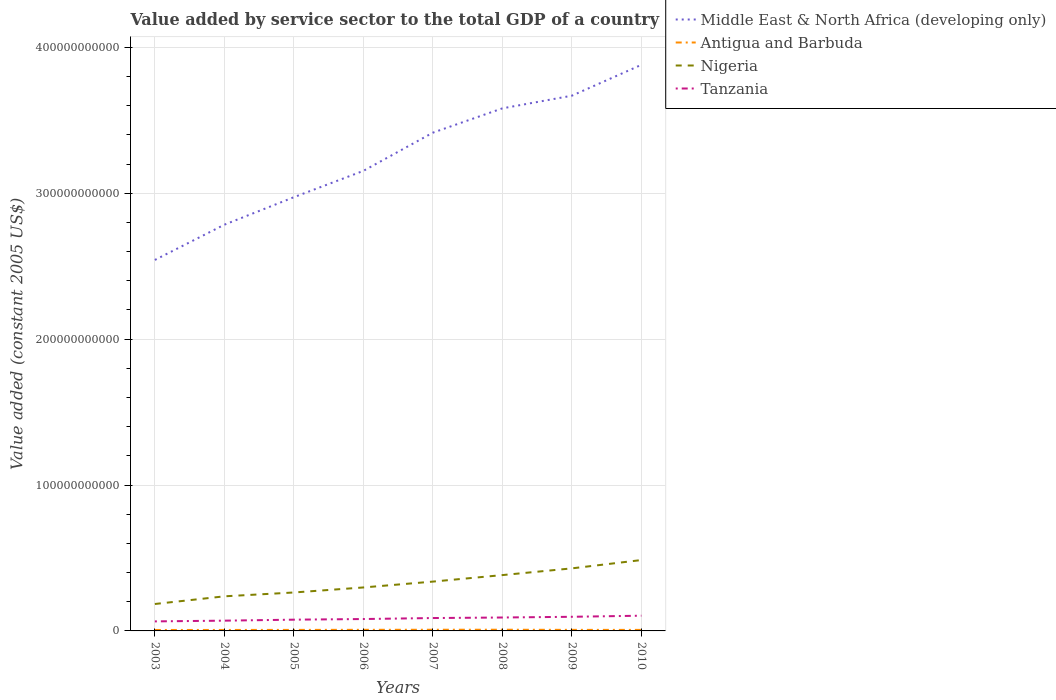How many different coloured lines are there?
Provide a short and direct response. 4. Does the line corresponding to Antigua and Barbuda intersect with the line corresponding to Tanzania?
Provide a succinct answer. No. Across all years, what is the maximum value added by service sector in Middle East & North Africa (developing only)?
Your answer should be very brief. 2.54e+11. What is the total value added by service sector in Nigeria in the graph?
Provide a short and direct response. -4.61e+09. What is the difference between the highest and the second highest value added by service sector in Tanzania?
Provide a succinct answer. 3.91e+09. What is the difference between the highest and the lowest value added by service sector in Antigua and Barbuda?
Keep it short and to the point. 3. How many years are there in the graph?
Your answer should be very brief. 8. What is the difference between two consecutive major ticks on the Y-axis?
Provide a short and direct response. 1.00e+11. How many legend labels are there?
Your response must be concise. 4. What is the title of the graph?
Provide a succinct answer. Value added by service sector to the total GDP of a country. Does "Paraguay" appear as one of the legend labels in the graph?
Your answer should be compact. No. What is the label or title of the X-axis?
Ensure brevity in your answer.  Years. What is the label or title of the Y-axis?
Provide a short and direct response. Value added (constant 2005 US$). What is the Value added (constant 2005 US$) of Middle East & North Africa (developing only) in 2003?
Your answer should be very brief. 2.54e+11. What is the Value added (constant 2005 US$) of Antigua and Barbuda in 2003?
Give a very brief answer. 6.45e+08. What is the Value added (constant 2005 US$) in Nigeria in 2003?
Provide a succinct answer. 1.85e+1. What is the Value added (constant 2005 US$) in Tanzania in 2003?
Your answer should be compact. 6.53e+09. What is the Value added (constant 2005 US$) in Middle East & North Africa (developing only) in 2004?
Your answer should be very brief. 2.78e+11. What is the Value added (constant 2005 US$) in Antigua and Barbuda in 2004?
Provide a succinct answer. 6.69e+08. What is the Value added (constant 2005 US$) of Nigeria in 2004?
Offer a terse response. 2.37e+1. What is the Value added (constant 2005 US$) in Tanzania in 2004?
Provide a short and direct response. 7.04e+09. What is the Value added (constant 2005 US$) in Middle East & North Africa (developing only) in 2005?
Keep it short and to the point. 2.97e+11. What is the Value added (constant 2005 US$) of Antigua and Barbuda in 2005?
Your answer should be compact. 7.00e+08. What is the Value added (constant 2005 US$) in Nigeria in 2005?
Keep it short and to the point. 2.63e+1. What is the Value added (constant 2005 US$) of Tanzania in 2005?
Offer a terse response. 7.71e+09. What is the Value added (constant 2005 US$) in Middle East & North Africa (developing only) in 2006?
Your answer should be compact. 3.15e+11. What is the Value added (constant 2005 US$) in Antigua and Barbuda in 2006?
Provide a succinct answer. 7.54e+08. What is the Value added (constant 2005 US$) of Nigeria in 2006?
Keep it short and to the point. 2.98e+1. What is the Value added (constant 2005 US$) of Tanzania in 2006?
Offer a very short reply. 8.15e+09. What is the Value added (constant 2005 US$) of Middle East & North Africa (developing only) in 2007?
Offer a terse response. 3.42e+11. What is the Value added (constant 2005 US$) of Antigua and Barbuda in 2007?
Make the answer very short. 8.07e+08. What is the Value added (constant 2005 US$) in Nigeria in 2007?
Give a very brief answer. 3.38e+1. What is the Value added (constant 2005 US$) in Tanzania in 2007?
Ensure brevity in your answer.  8.83e+09. What is the Value added (constant 2005 US$) of Middle East & North Africa (developing only) in 2008?
Ensure brevity in your answer.  3.58e+11. What is the Value added (constant 2005 US$) in Antigua and Barbuda in 2008?
Ensure brevity in your answer.  8.23e+08. What is the Value added (constant 2005 US$) of Nigeria in 2008?
Offer a very short reply. 3.83e+1. What is the Value added (constant 2005 US$) in Tanzania in 2008?
Make the answer very short. 9.20e+09. What is the Value added (constant 2005 US$) of Middle East & North Africa (developing only) in 2009?
Your answer should be compact. 3.67e+11. What is the Value added (constant 2005 US$) of Antigua and Barbuda in 2009?
Keep it short and to the point. 7.27e+08. What is the Value added (constant 2005 US$) of Nigeria in 2009?
Your answer should be compact. 4.29e+1. What is the Value added (constant 2005 US$) in Tanzania in 2009?
Your answer should be very brief. 9.69e+09. What is the Value added (constant 2005 US$) of Middle East & North Africa (developing only) in 2010?
Your answer should be very brief. 3.88e+11. What is the Value added (constant 2005 US$) of Antigua and Barbuda in 2010?
Your answer should be compact. 7.00e+08. What is the Value added (constant 2005 US$) in Nigeria in 2010?
Provide a short and direct response. 4.86e+1. What is the Value added (constant 2005 US$) of Tanzania in 2010?
Offer a terse response. 1.04e+1. Across all years, what is the maximum Value added (constant 2005 US$) in Middle East & North Africa (developing only)?
Make the answer very short. 3.88e+11. Across all years, what is the maximum Value added (constant 2005 US$) of Antigua and Barbuda?
Ensure brevity in your answer.  8.23e+08. Across all years, what is the maximum Value added (constant 2005 US$) in Nigeria?
Make the answer very short. 4.86e+1. Across all years, what is the maximum Value added (constant 2005 US$) of Tanzania?
Make the answer very short. 1.04e+1. Across all years, what is the minimum Value added (constant 2005 US$) in Middle East & North Africa (developing only)?
Offer a very short reply. 2.54e+11. Across all years, what is the minimum Value added (constant 2005 US$) of Antigua and Barbuda?
Give a very brief answer. 6.45e+08. Across all years, what is the minimum Value added (constant 2005 US$) of Nigeria?
Provide a short and direct response. 1.85e+1. Across all years, what is the minimum Value added (constant 2005 US$) of Tanzania?
Offer a terse response. 6.53e+09. What is the total Value added (constant 2005 US$) of Middle East & North Africa (developing only) in the graph?
Ensure brevity in your answer.  2.60e+12. What is the total Value added (constant 2005 US$) in Antigua and Barbuda in the graph?
Provide a succinct answer. 5.83e+09. What is the total Value added (constant 2005 US$) of Nigeria in the graph?
Ensure brevity in your answer.  2.62e+11. What is the total Value added (constant 2005 US$) in Tanzania in the graph?
Your response must be concise. 6.76e+1. What is the difference between the Value added (constant 2005 US$) of Middle East & North Africa (developing only) in 2003 and that in 2004?
Your answer should be very brief. -2.42e+1. What is the difference between the Value added (constant 2005 US$) in Antigua and Barbuda in 2003 and that in 2004?
Provide a succinct answer. -2.36e+07. What is the difference between the Value added (constant 2005 US$) of Nigeria in 2003 and that in 2004?
Your response must be concise. -5.26e+09. What is the difference between the Value added (constant 2005 US$) of Tanzania in 2003 and that in 2004?
Provide a short and direct response. -5.07e+08. What is the difference between the Value added (constant 2005 US$) of Middle East & North Africa (developing only) in 2003 and that in 2005?
Provide a succinct answer. -4.30e+1. What is the difference between the Value added (constant 2005 US$) in Antigua and Barbuda in 2003 and that in 2005?
Your answer should be very brief. -5.47e+07. What is the difference between the Value added (constant 2005 US$) of Nigeria in 2003 and that in 2005?
Your answer should be compact. -7.89e+09. What is the difference between the Value added (constant 2005 US$) of Tanzania in 2003 and that in 2005?
Your answer should be very brief. -1.18e+09. What is the difference between the Value added (constant 2005 US$) in Middle East & North Africa (developing only) in 2003 and that in 2006?
Offer a very short reply. -6.11e+1. What is the difference between the Value added (constant 2005 US$) in Antigua and Barbuda in 2003 and that in 2006?
Make the answer very short. -1.09e+08. What is the difference between the Value added (constant 2005 US$) of Nigeria in 2003 and that in 2006?
Give a very brief answer. -1.13e+1. What is the difference between the Value added (constant 2005 US$) of Tanzania in 2003 and that in 2006?
Make the answer very short. -1.62e+09. What is the difference between the Value added (constant 2005 US$) in Middle East & North Africa (developing only) in 2003 and that in 2007?
Give a very brief answer. -8.73e+1. What is the difference between the Value added (constant 2005 US$) in Antigua and Barbuda in 2003 and that in 2007?
Ensure brevity in your answer.  -1.61e+08. What is the difference between the Value added (constant 2005 US$) of Nigeria in 2003 and that in 2007?
Offer a very short reply. -1.54e+1. What is the difference between the Value added (constant 2005 US$) of Tanzania in 2003 and that in 2007?
Offer a terse response. -2.30e+09. What is the difference between the Value added (constant 2005 US$) in Middle East & North Africa (developing only) in 2003 and that in 2008?
Your answer should be compact. -1.04e+11. What is the difference between the Value added (constant 2005 US$) in Antigua and Barbuda in 2003 and that in 2008?
Provide a succinct answer. -1.78e+08. What is the difference between the Value added (constant 2005 US$) in Nigeria in 2003 and that in 2008?
Give a very brief answer. -1.98e+1. What is the difference between the Value added (constant 2005 US$) of Tanzania in 2003 and that in 2008?
Give a very brief answer. -2.67e+09. What is the difference between the Value added (constant 2005 US$) of Middle East & North Africa (developing only) in 2003 and that in 2009?
Offer a very short reply. -1.13e+11. What is the difference between the Value added (constant 2005 US$) of Antigua and Barbuda in 2003 and that in 2009?
Offer a very short reply. -8.20e+07. What is the difference between the Value added (constant 2005 US$) in Nigeria in 2003 and that in 2009?
Ensure brevity in your answer.  -2.44e+1. What is the difference between the Value added (constant 2005 US$) in Tanzania in 2003 and that in 2009?
Offer a terse response. -3.16e+09. What is the difference between the Value added (constant 2005 US$) in Middle East & North Africa (developing only) in 2003 and that in 2010?
Offer a terse response. -1.34e+11. What is the difference between the Value added (constant 2005 US$) of Antigua and Barbuda in 2003 and that in 2010?
Ensure brevity in your answer.  -5.50e+07. What is the difference between the Value added (constant 2005 US$) of Nigeria in 2003 and that in 2010?
Provide a succinct answer. -3.01e+1. What is the difference between the Value added (constant 2005 US$) in Tanzania in 2003 and that in 2010?
Offer a very short reply. -3.91e+09. What is the difference between the Value added (constant 2005 US$) of Middle East & North Africa (developing only) in 2004 and that in 2005?
Provide a succinct answer. -1.88e+1. What is the difference between the Value added (constant 2005 US$) in Antigua and Barbuda in 2004 and that in 2005?
Offer a terse response. -3.11e+07. What is the difference between the Value added (constant 2005 US$) in Nigeria in 2004 and that in 2005?
Offer a terse response. -2.63e+09. What is the difference between the Value added (constant 2005 US$) in Tanzania in 2004 and that in 2005?
Ensure brevity in your answer.  -6.78e+08. What is the difference between the Value added (constant 2005 US$) of Middle East & North Africa (developing only) in 2004 and that in 2006?
Your answer should be very brief. -3.69e+1. What is the difference between the Value added (constant 2005 US$) in Antigua and Barbuda in 2004 and that in 2006?
Make the answer very short. -8.52e+07. What is the difference between the Value added (constant 2005 US$) in Nigeria in 2004 and that in 2006?
Offer a terse response. -6.08e+09. What is the difference between the Value added (constant 2005 US$) in Tanzania in 2004 and that in 2006?
Give a very brief answer. -1.11e+09. What is the difference between the Value added (constant 2005 US$) of Middle East & North Africa (developing only) in 2004 and that in 2007?
Provide a succinct answer. -6.31e+1. What is the difference between the Value added (constant 2005 US$) in Antigua and Barbuda in 2004 and that in 2007?
Your answer should be compact. -1.38e+08. What is the difference between the Value added (constant 2005 US$) of Nigeria in 2004 and that in 2007?
Your response must be concise. -1.01e+1. What is the difference between the Value added (constant 2005 US$) of Tanzania in 2004 and that in 2007?
Your answer should be compact. -1.79e+09. What is the difference between the Value added (constant 2005 US$) in Middle East & North Africa (developing only) in 2004 and that in 2008?
Give a very brief answer. -7.98e+1. What is the difference between the Value added (constant 2005 US$) in Antigua and Barbuda in 2004 and that in 2008?
Offer a very short reply. -1.55e+08. What is the difference between the Value added (constant 2005 US$) of Nigeria in 2004 and that in 2008?
Provide a short and direct response. -1.46e+1. What is the difference between the Value added (constant 2005 US$) in Tanzania in 2004 and that in 2008?
Keep it short and to the point. -2.16e+09. What is the difference between the Value added (constant 2005 US$) in Middle East & North Africa (developing only) in 2004 and that in 2009?
Your answer should be very brief. -8.84e+1. What is the difference between the Value added (constant 2005 US$) of Antigua and Barbuda in 2004 and that in 2009?
Provide a short and direct response. -5.84e+07. What is the difference between the Value added (constant 2005 US$) in Nigeria in 2004 and that in 2009?
Your response must be concise. -1.92e+1. What is the difference between the Value added (constant 2005 US$) in Tanzania in 2004 and that in 2009?
Your answer should be compact. -2.65e+09. What is the difference between the Value added (constant 2005 US$) of Middle East & North Africa (developing only) in 2004 and that in 2010?
Give a very brief answer. -1.10e+11. What is the difference between the Value added (constant 2005 US$) of Antigua and Barbuda in 2004 and that in 2010?
Your answer should be very brief. -3.14e+07. What is the difference between the Value added (constant 2005 US$) in Nigeria in 2004 and that in 2010?
Provide a succinct answer. -2.49e+1. What is the difference between the Value added (constant 2005 US$) of Tanzania in 2004 and that in 2010?
Give a very brief answer. -3.41e+09. What is the difference between the Value added (constant 2005 US$) in Middle East & North Africa (developing only) in 2005 and that in 2006?
Make the answer very short. -1.81e+1. What is the difference between the Value added (constant 2005 US$) in Antigua and Barbuda in 2005 and that in 2006?
Provide a succinct answer. -5.41e+07. What is the difference between the Value added (constant 2005 US$) of Nigeria in 2005 and that in 2006?
Ensure brevity in your answer.  -3.45e+09. What is the difference between the Value added (constant 2005 US$) in Tanzania in 2005 and that in 2006?
Offer a terse response. -4.34e+08. What is the difference between the Value added (constant 2005 US$) of Middle East & North Africa (developing only) in 2005 and that in 2007?
Your answer should be very brief. -4.43e+1. What is the difference between the Value added (constant 2005 US$) in Antigua and Barbuda in 2005 and that in 2007?
Your answer should be compact. -1.07e+08. What is the difference between the Value added (constant 2005 US$) in Nigeria in 2005 and that in 2007?
Your response must be concise. -7.46e+09. What is the difference between the Value added (constant 2005 US$) of Tanzania in 2005 and that in 2007?
Provide a succinct answer. -1.12e+09. What is the difference between the Value added (constant 2005 US$) in Middle East & North Africa (developing only) in 2005 and that in 2008?
Keep it short and to the point. -6.09e+1. What is the difference between the Value added (constant 2005 US$) in Antigua and Barbuda in 2005 and that in 2008?
Make the answer very short. -1.24e+08. What is the difference between the Value added (constant 2005 US$) of Nigeria in 2005 and that in 2008?
Keep it short and to the point. -1.19e+1. What is the difference between the Value added (constant 2005 US$) in Tanzania in 2005 and that in 2008?
Your answer should be very brief. -1.48e+09. What is the difference between the Value added (constant 2005 US$) of Middle East & North Africa (developing only) in 2005 and that in 2009?
Your answer should be very brief. -6.96e+1. What is the difference between the Value added (constant 2005 US$) in Antigua and Barbuda in 2005 and that in 2009?
Keep it short and to the point. -2.74e+07. What is the difference between the Value added (constant 2005 US$) of Nigeria in 2005 and that in 2009?
Offer a terse response. -1.65e+1. What is the difference between the Value added (constant 2005 US$) in Tanzania in 2005 and that in 2009?
Your response must be concise. -1.98e+09. What is the difference between the Value added (constant 2005 US$) in Middle East & North Africa (developing only) in 2005 and that in 2010?
Provide a succinct answer. -9.07e+1. What is the difference between the Value added (constant 2005 US$) in Antigua and Barbuda in 2005 and that in 2010?
Your answer should be compact. -2.72e+05. What is the difference between the Value added (constant 2005 US$) in Nigeria in 2005 and that in 2010?
Give a very brief answer. -2.22e+1. What is the difference between the Value added (constant 2005 US$) of Tanzania in 2005 and that in 2010?
Your response must be concise. -2.73e+09. What is the difference between the Value added (constant 2005 US$) of Middle East & North Africa (developing only) in 2006 and that in 2007?
Your answer should be very brief. -2.62e+1. What is the difference between the Value added (constant 2005 US$) in Antigua and Barbuda in 2006 and that in 2007?
Keep it short and to the point. -5.26e+07. What is the difference between the Value added (constant 2005 US$) in Nigeria in 2006 and that in 2007?
Provide a short and direct response. -4.01e+09. What is the difference between the Value added (constant 2005 US$) of Tanzania in 2006 and that in 2007?
Keep it short and to the point. -6.82e+08. What is the difference between the Value added (constant 2005 US$) of Middle East & North Africa (developing only) in 2006 and that in 2008?
Offer a terse response. -4.29e+1. What is the difference between the Value added (constant 2005 US$) in Antigua and Barbuda in 2006 and that in 2008?
Give a very brief answer. -6.95e+07. What is the difference between the Value added (constant 2005 US$) in Nigeria in 2006 and that in 2008?
Provide a succinct answer. -8.48e+09. What is the difference between the Value added (constant 2005 US$) in Tanzania in 2006 and that in 2008?
Keep it short and to the point. -1.05e+09. What is the difference between the Value added (constant 2005 US$) in Middle East & North Africa (developing only) in 2006 and that in 2009?
Provide a succinct answer. -5.15e+1. What is the difference between the Value added (constant 2005 US$) of Antigua and Barbuda in 2006 and that in 2009?
Provide a succinct answer. 2.68e+07. What is the difference between the Value added (constant 2005 US$) of Nigeria in 2006 and that in 2009?
Make the answer very short. -1.31e+1. What is the difference between the Value added (constant 2005 US$) in Tanzania in 2006 and that in 2009?
Provide a short and direct response. -1.54e+09. What is the difference between the Value added (constant 2005 US$) of Middle East & North Africa (developing only) in 2006 and that in 2010?
Your response must be concise. -7.27e+1. What is the difference between the Value added (constant 2005 US$) of Antigua and Barbuda in 2006 and that in 2010?
Your answer should be very brief. 5.38e+07. What is the difference between the Value added (constant 2005 US$) of Nigeria in 2006 and that in 2010?
Keep it short and to the point. -1.88e+1. What is the difference between the Value added (constant 2005 US$) of Tanzania in 2006 and that in 2010?
Keep it short and to the point. -2.29e+09. What is the difference between the Value added (constant 2005 US$) in Middle East & North Africa (developing only) in 2007 and that in 2008?
Give a very brief answer. -1.67e+1. What is the difference between the Value added (constant 2005 US$) of Antigua and Barbuda in 2007 and that in 2008?
Your answer should be very brief. -1.68e+07. What is the difference between the Value added (constant 2005 US$) in Nigeria in 2007 and that in 2008?
Provide a short and direct response. -4.47e+09. What is the difference between the Value added (constant 2005 US$) of Tanzania in 2007 and that in 2008?
Provide a short and direct response. -3.64e+08. What is the difference between the Value added (constant 2005 US$) of Middle East & North Africa (developing only) in 2007 and that in 2009?
Your answer should be compact. -2.53e+1. What is the difference between the Value added (constant 2005 US$) in Antigua and Barbuda in 2007 and that in 2009?
Give a very brief answer. 7.94e+07. What is the difference between the Value added (constant 2005 US$) in Nigeria in 2007 and that in 2009?
Give a very brief answer. -9.07e+09. What is the difference between the Value added (constant 2005 US$) in Tanzania in 2007 and that in 2009?
Your response must be concise. -8.60e+08. What is the difference between the Value added (constant 2005 US$) of Middle East & North Africa (developing only) in 2007 and that in 2010?
Keep it short and to the point. -4.65e+1. What is the difference between the Value added (constant 2005 US$) of Antigua and Barbuda in 2007 and that in 2010?
Keep it short and to the point. 1.06e+08. What is the difference between the Value added (constant 2005 US$) of Nigeria in 2007 and that in 2010?
Offer a terse response. -1.48e+1. What is the difference between the Value added (constant 2005 US$) of Tanzania in 2007 and that in 2010?
Give a very brief answer. -1.61e+09. What is the difference between the Value added (constant 2005 US$) of Middle East & North Africa (developing only) in 2008 and that in 2009?
Your response must be concise. -8.68e+09. What is the difference between the Value added (constant 2005 US$) of Antigua and Barbuda in 2008 and that in 2009?
Provide a short and direct response. 9.62e+07. What is the difference between the Value added (constant 2005 US$) in Nigeria in 2008 and that in 2009?
Offer a terse response. -4.61e+09. What is the difference between the Value added (constant 2005 US$) in Tanzania in 2008 and that in 2009?
Make the answer very short. -4.96e+08. What is the difference between the Value added (constant 2005 US$) in Middle East & North Africa (developing only) in 2008 and that in 2010?
Keep it short and to the point. -2.98e+1. What is the difference between the Value added (constant 2005 US$) in Antigua and Barbuda in 2008 and that in 2010?
Make the answer very short. 1.23e+08. What is the difference between the Value added (constant 2005 US$) in Nigeria in 2008 and that in 2010?
Your answer should be very brief. -1.03e+1. What is the difference between the Value added (constant 2005 US$) in Tanzania in 2008 and that in 2010?
Offer a very short reply. -1.25e+09. What is the difference between the Value added (constant 2005 US$) of Middle East & North Africa (developing only) in 2009 and that in 2010?
Offer a terse response. -2.12e+1. What is the difference between the Value added (constant 2005 US$) of Antigua and Barbuda in 2009 and that in 2010?
Give a very brief answer. 2.71e+07. What is the difference between the Value added (constant 2005 US$) in Nigeria in 2009 and that in 2010?
Ensure brevity in your answer.  -5.70e+09. What is the difference between the Value added (constant 2005 US$) of Tanzania in 2009 and that in 2010?
Offer a terse response. -7.53e+08. What is the difference between the Value added (constant 2005 US$) in Middle East & North Africa (developing only) in 2003 and the Value added (constant 2005 US$) in Antigua and Barbuda in 2004?
Provide a succinct answer. 2.54e+11. What is the difference between the Value added (constant 2005 US$) in Middle East & North Africa (developing only) in 2003 and the Value added (constant 2005 US$) in Nigeria in 2004?
Your response must be concise. 2.31e+11. What is the difference between the Value added (constant 2005 US$) in Middle East & North Africa (developing only) in 2003 and the Value added (constant 2005 US$) in Tanzania in 2004?
Provide a succinct answer. 2.47e+11. What is the difference between the Value added (constant 2005 US$) in Antigua and Barbuda in 2003 and the Value added (constant 2005 US$) in Nigeria in 2004?
Provide a short and direct response. -2.31e+1. What is the difference between the Value added (constant 2005 US$) in Antigua and Barbuda in 2003 and the Value added (constant 2005 US$) in Tanzania in 2004?
Make the answer very short. -6.39e+09. What is the difference between the Value added (constant 2005 US$) in Nigeria in 2003 and the Value added (constant 2005 US$) in Tanzania in 2004?
Give a very brief answer. 1.14e+1. What is the difference between the Value added (constant 2005 US$) in Middle East & North Africa (developing only) in 2003 and the Value added (constant 2005 US$) in Antigua and Barbuda in 2005?
Ensure brevity in your answer.  2.54e+11. What is the difference between the Value added (constant 2005 US$) of Middle East & North Africa (developing only) in 2003 and the Value added (constant 2005 US$) of Nigeria in 2005?
Make the answer very short. 2.28e+11. What is the difference between the Value added (constant 2005 US$) of Middle East & North Africa (developing only) in 2003 and the Value added (constant 2005 US$) of Tanzania in 2005?
Keep it short and to the point. 2.47e+11. What is the difference between the Value added (constant 2005 US$) of Antigua and Barbuda in 2003 and the Value added (constant 2005 US$) of Nigeria in 2005?
Ensure brevity in your answer.  -2.57e+1. What is the difference between the Value added (constant 2005 US$) in Antigua and Barbuda in 2003 and the Value added (constant 2005 US$) in Tanzania in 2005?
Make the answer very short. -7.07e+09. What is the difference between the Value added (constant 2005 US$) of Nigeria in 2003 and the Value added (constant 2005 US$) of Tanzania in 2005?
Your answer should be very brief. 1.07e+1. What is the difference between the Value added (constant 2005 US$) in Middle East & North Africa (developing only) in 2003 and the Value added (constant 2005 US$) in Antigua and Barbuda in 2006?
Your answer should be very brief. 2.54e+11. What is the difference between the Value added (constant 2005 US$) in Middle East & North Africa (developing only) in 2003 and the Value added (constant 2005 US$) in Nigeria in 2006?
Offer a terse response. 2.24e+11. What is the difference between the Value added (constant 2005 US$) of Middle East & North Africa (developing only) in 2003 and the Value added (constant 2005 US$) of Tanzania in 2006?
Your answer should be very brief. 2.46e+11. What is the difference between the Value added (constant 2005 US$) of Antigua and Barbuda in 2003 and the Value added (constant 2005 US$) of Nigeria in 2006?
Your response must be concise. -2.92e+1. What is the difference between the Value added (constant 2005 US$) of Antigua and Barbuda in 2003 and the Value added (constant 2005 US$) of Tanzania in 2006?
Your answer should be compact. -7.50e+09. What is the difference between the Value added (constant 2005 US$) in Nigeria in 2003 and the Value added (constant 2005 US$) in Tanzania in 2006?
Your response must be concise. 1.03e+1. What is the difference between the Value added (constant 2005 US$) in Middle East & North Africa (developing only) in 2003 and the Value added (constant 2005 US$) in Antigua and Barbuda in 2007?
Keep it short and to the point. 2.53e+11. What is the difference between the Value added (constant 2005 US$) of Middle East & North Africa (developing only) in 2003 and the Value added (constant 2005 US$) of Nigeria in 2007?
Your answer should be very brief. 2.20e+11. What is the difference between the Value added (constant 2005 US$) of Middle East & North Africa (developing only) in 2003 and the Value added (constant 2005 US$) of Tanzania in 2007?
Offer a very short reply. 2.45e+11. What is the difference between the Value added (constant 2005 US$) in Antigua and Barbuda in 2003 and the Value added (constant 2005 US$) in Nigeria in 2007?
Give a very brief answer. -3.32e+1. What is the difference between the Value added (constant 2005 US$) in Antigua and Barbuda in 2003 and the Value added (constant 2005 US$) in Tanzania in 2007?
Your answer should be very brief. -8.19e+09. What is the difference between the Value added (constant 2005 US$) of Nigeria in 2003 and the Value added (constant 2005 US$) of Tanzania in 2007?
Keep it short and to the point. 9.63e+09. What is the difference between the Value added (constant 2005 US$) in Middle East & North Africa (developing only) in 2003 and the Value added (constant 2005 US$) in Antigua and Barbuda in 2008?
Your response must be concise. 2.53e+11. What is the difference between the Value added (constant 2005 US$) in Middle East & North Africa (developing only) in 2003 and the Value added (constant 2005 US$) in Nigeria in 2008?
Give a very brief answer. 2.16e+11. What is the difference between the Value added (constant 2005 US$) of Middle East & North Africa (developing only) in 2003 and the Value added (constant 2005 US$) of Tanzania in 2008?
Provide a short and direct response. 2.45e+11. What is the difference between the Value added (constant 2005 US$) in Antigua and Barbuda in 2003 and the Value added (constant 2005 US$) in Nigeria in 2008?
Provide a succinct answer. -3.76e+1. What is the difference between the Value added (constant 2005 US$) of Antigua and Barbuda in 2003 and the Value added (constant 2005 US$) of Tanzania in 2008?
Provide a succinct answer. -8.55e+09. What is the difference between the Value added (constant 2005 US$) in Nigeria in 2003 and the Value added (constant 2005 US$) in Tanzania in 2008?
Ensure brevity in your answer.  9.26e+09. What is the difference between the Value added (constant 2005 US$) in Middle East & North Africa (developing only) in 2003 and the Value added (constant 2005 US$) in Antigua and Barbuda in 2009?
Make the answer very short. 2.54e+11. What is the difference between the Value added (constant 2005 US$) of Middle East & North Africa (developing only) in 2003 and the Value added (constant 2005 US$) of Nigeria in 2009?
Your answer should be compact. 2.11e+11. What is the difference between the Value added (constant 2005 US$) in Middle East & North Africa (developing only) in 2003 and the Value added (constant 2005 US$) in Tanzania in 2009?
Your answer should be very brief. 2.45e+11. What is the difference between the Value added (constant 2005 US$) of Antigua and Barbuda in 2003 and the Value added (constant 2005 US$) of Nigeria in 2009?
Make the answer very short. -4.22e+1. What is the difference between the Value added (constant 2005 US$) in Antigua and Barbuda in 2003 and the Value added (constant 2005 US$) in Tanzania in 2009?
Provide a succinct answer. -9.05e+09. What is the difference between the Value added (constant 2005 US$) in Nigeria in 2003 and the Value added (constant 2005 US$) in Tanzania in 2009?
Ensure brevity in your answer.  8.77e+09. What is the difference between the Value added (constant 2005 US$) of Middle East & North Africa (developing only) in 2003 and the Value added (constant 2005 US$) of Antigua and Barbuda in 2010?
Provide a succinct answer. 2.54e+11. What is the difference between the Value added (constant 2005 US$) in Middle East & North Africa (developing only) in 2003 and the Value added (constant 2005 US$) in Nigeria in 2010?
Your answer should be very brief. 2.06e+11. What is the difference between the Value added (constant 2005 US$) in Middle East & North Africa (developing only) in 2003 and the Value added (constant 2005 US$) in Tanzania in 2010?
Your answer should be compact. 2.44e+11. What is the difference between the Value added (constant 2005 US$) in Antigua and Barbuda in 2003 and the Value added (constant 2005 US$) in Nigeria in 2010?
Keep it short and to the point. -4.79e+1. What is the difference between the Value added (constant 2005 US$) of Antigua and Barbuda in 2003 and the Value added (constant 2005 US$) of Tanzania in 2010?
Provide a short and direct response. -9.80e+09. What is the difference between the Value added (constant 2005 US$) in Nigeria in 2003 and the Value added (constant 2005 US$) in Tanzania in 2010?
Offer a very short reply. 8.01e+09. What is the difference between the Value added (constant 2005 US$) of Middle East & North Africa (developing only) in 2004 and the Value added (constant 2005 US$) of Antigua and Barbuda in 2005?
Make the answer very short. 2.78e+11. What is the difference between the Value added (constant 2005 US$) of Middle East & North Africa (developing only) in 2004 and the Value added (constant 2005 US$) of Nigeria in 2005?
Ensure brevity in your answer.  2.52e+11. What is the difference between the Value added (constant 2005 US$) in Middle East & North Africa (developing only) in 2004 and the Value added (constant 2005 US$) in Tanzania in 2005?
Offer a terse response. 2.71e+11. What is the difference between the Value added (constant 2005 US$) in Antigua and Barbuda in 2004 and the Value added (constant 2005 US$) in Nigeria in 2005?
Make the answer very short. -2.57e+1. What is the difference between the Value added (constant 2005 US$) of Antigua and Barbuda in 2004 and the Value added (constant 2005 US$) of Tanzania in 2005?
Give a very brief answer. -7.05e+09. What is the difference between the Value added (constant 2005 US$) in Nigeria in 2004 and the Value added (constant 2005 US$) in Tanzania in 2005?
Make the answer very short. 1.60e+1. What is the difference between the Value added (constant 2005 US$) in Middle East & North Africa (developing only) in 2004 and the Value added (constant 2005 US$) in Antigua and Barbuda in 2006?
Your answer should be compact. 2.78e+11. What is the difference between the Value added (constant 2005 US$) of Middle East & North Africa (developing only) in 2004 and the Value added (constant 2005 US$) of Nigeria in 2006?
Ensure brevity in your answer.  2.49e+11. What is the difference between the Value added (constant 2005 US$) of Middle East & North Africa (developing only) in 2004 and the Value added (constant 2005 US$) of Tanzania in 2006?
Provide a short and direct response. 2.70e+11. What is the difference between the Value added (constant 2005 US$) of Antigua and Barbuda in 2004 and the Value added (constant 2005 US$) of Nigeria in 2006?
Offer a very short reply. -2.91e+1. What is the difference between the Value added (constant 2005 US$) in Antigua and Barbuda in 2004 and the Value added (constant 2005 US$) in Tanzania in 2006?
Ensure brevity in your answer.  -7.48e+09. What is the difference between the Value added (constant 2005 US$) of Nigeria in 2004 and the Value added (constant 2005 US$) of Tanzania in 2006?
Make the answer very short. 1.56e+1. What is the difference between the Value added (constant 2005 US$) in Middle East & North Africa (developing only) in 2004 and the Value added (constant 2005 US$) in Antigua and Barbuda in 2007?
Keep it short and to the point. 2.78e+11. What is the difference between the Value added (constant 2005 US$) in Middle East & North Africa (developing only) in 2004 and the Value added (constant 2005 US$) in Nigeria in 2007?
Provide a short and direct response. 2.45e+11. What is the difference between the Value added (constant 2005 US$) in Middle East & North Africa (developing only) in 2004 and the Value added (constant 2005 US$) in Tanzania in 2007?
Provide a short and direct response. 2.70e+11. What is the difference between the Value added (constant 2005 US$) of Antigua and Barbuda in 2004 and the Value added (constant 2005 US$) of Nigeria in 2007?
Give a very brief answer. -3.31e+1. What is the difference between the Value added (constant 2005 US$) of Antigua and Barbuda in 2004 and the Value added (constant 2005 US$) of Tanzania in 2007?
Provide a short and direct response. -8.16e+09. What is the difference between the Value added (constant 2005 US$) of Nigeria in 2004 and the Value added (constant 2005 US$) of Tanzania in 2007?
Provide a succinct answer. 1.49e+1. What is the difference between the Value added (constant 2005 US$) in Middle East & North Africa (developing only) in 2004 and the Value added (constant 2005 US$) in Antigua and Barbuda in 2008?
Make the answer very short. 2.78e+11. What is the difference between the Value added (constant 2005 US$) in Middle East & North Africa (developing only) in 2004 and the Value added (constant 2005 US$) in Nigeria in 2008?
Provide a succinct answer. 2.40e+11. What is the difference between the Value added (constant 2005 US$) of Middle East & North Africa (developing only) in 2004 and the Value added (constant 2005 US$) of Tanzania in 2008?
Your answer should be very brief. 2.69e+11. What is the difference between the Value added (constant 2005 US$) in Antigua and Barbuda in 2004 and the Value added (constant 2005 US$) in Nigeria in 2008?
Offer a very short reply. -3.76e+1. What is the difference between the Value added (constant 2005 US$) in Antigua and Barbuda in 2004 and the Value added (constant 2005 US$) in Tanzania in 2008?
Provide a short and direct response. -8.53e+09. What is the difference between the Value added (constant 2005 US$) in Nigeria in 2004 and the Value added (constant 2005 US$) in Tanzania in 2008?
Offer a very short reply. 1.45e+1. What is the difference between the Value added (constant 2005 US$) of Middle East & North Africa (developing only) in 2004 and the Value added (constant 2005 US$) of Antigua and Barbuda in 2009?
Keep it short and to the point. 2.78e+11. What is the difference between the Value added (constant 2005 US$) of Middle East & North Africa (developing only) in 2004 and the Value added (constant 2005 US$) of Nigeria in 2009?
Provide a short and direct response. 2.36e+11. What is the difference between the Value added (constant 2005 US$) in Middle East & North Africa (developing only) in 2004 and the Value added (constant 2005 US$) in Tanzania in 2009?
Offer a terse response. 2.69e+11. What is the difference between the Value added (constant 2005 US$) of Antigua and Barbuda in 2004 and the Value added (constant 2005 US$) of Nigeria in 2009?
Offer a terse response. -4.22e+1. What is the difference between the Value added (constant 2005 US$) in Antigua and Barbuda in 2004 and the Value added (constant 2005 US$) in Tanzania in 2009?
Make the answer very short. -9.02e+09. What is the difference between the Value added (constant 2005 US$) of Nigeria in 2004 and the Value added (constant 2005 US$) of Tanzania in 2009?
Keep it short and to the point. 1.40e+1. What is the difference between the Value added (constant 2005 US$) in Middle East & North Africa (developing only) in 2004 and the Value added (constant 2005 US$) in Antigua and Barbuda in 2010?
Your answer should be compact. 2.78e+11. What is the difference between the Value added (constant 2005 US$) in Middle East & North Africa (developing only) in 2004 and the Value added (constant 2005 US$) in Nigeria in 2010?
Your answer should be compact. 2.30e+11. What is the difference between the Value added (constant 2005 US$) in Middle East & North Africa (developing only) in 2004 and the Value added (constant 2005 US$) in Tanzania in 2010?
Offer a very short reply. 2.68e+11. What is the difference between the Value added (constant 2005 US$) of Antigua and Barbuda in 2004 and the Value added (constant 2005 US$) of Nigeria in 2010?
Offer a terse response. -4.79e+1. What is the difference between the Value added (constant 2005 US$) of Antigua and Barbuda in 2004 and the Value added (constant 2005 US$) of Tanzania in 2010?
Give a very brief answer. -9.77e+09. What is the difference between the Value added (constant 2005 US$) of Nigeria in 2004 and the Value added (constant 2005 US$) of Tanzania in 2010?
Provide a short and direct response. 1.33e+1. What is the difference between the Value added (constant 2005 US$) of Middle East & North Africa (developing only) in 2005 and the Value added (constant 2005 US$) of Antigua and Barbuda in 2006?
Your response must be concise. 2.97e+11. What is the difference between the Value added (constant 2005 US$) in Middle East & North Africa (developing only) in 2005 and the Value added (constant 2005 US$) in Nigeria in 2006?
Ensure brevity in your answer.  2.68e+11. What is the difference between the Value added (constant 2005 US$) of Middle East & North Africa (developing only) in 2005 and the Value added (constant 2005 US$) of Tanzania in 2006?
Your answer should be compact. 2.89e+11. What is the difference between the Value added (constant 2005 US$) in Antigua and Barbuda in 2005 and the Value added (constant 2005 US$) in Nigeria in 2006?
Give a very brief answer. -2.91e+1. What is the difference between the Value added (constant 2005 US$) of Antigua and Barbuda in 2005 and the Value added (constant 2005 US$) of Tanzania in 2006?
Provide a short and direct response. -7.45e+09. What is the difference between the Value added (constant 2005 US$) of Nigeria in 2005 and the Value added (constant 2005 US$) of Tanzania in 2006?
Offer a terse response. 1.82e+1. What is the difference between the Value added (constant 2005 US$) of Middle East & North Africa (developing only) in 2005 and the Value added (constant 2005 US$) of Antigua and Barbuda in 2007?
Your answer should be very brief. 2.97e+11. What is the difference between the Value added (constant 2005 US$) of Middle East & North Africa (developing only) in 2005 and the Value added (constant 2005 US$) of Nigeria in 2007?
Provide a short and direct response. 2.64e+11. What is the difference between the Value added (constant 2005 US$) in Middle East & North Africa (developing only) in 2005 and the Value added (constant 2005 US$) in Tanzania in 2007?
Your response must be concise. 2.88e+11. What is the difference between the Value added (constant 2005 US$) in Antigua and Barbuda in 2005 and the Value added (constant 2005 US$) in Nigeria in 2007?
Give a very brief answer. -3.31e+1. What is the difference between the Value added (constant 2005 US$) in Antigua and Barbuda in 2005 and the Value added (constant 2005 US$) in Tanzania in 2007?
Make the answer very short. -8.13e+09. What is the difference between the Value added (constant 2005 US$) of Nigeria in 2005 and the Value added (constant 2005 US$) of Tanzania in 2007?
Provide a short and direct response. 1.75e+1. What is the difference between the Value added (constant 2005 US$) in Middle East & North Africa (developing only) in 2005 and the Value added (constant 2005 US$) in Antigua and Barbuda in 2008?
Make the answer very short. 2.96e+11. What is the difference between the Value added (constant 2005 US$) in Middle East & North Africa (developing only) in 2005 and the Value added (constant 2005 US$) in Nigeria in 2008?
Ensure brevity in your answer.  2.59e+11. What is the difference between the Value added (constant 2005 US$) in Middle East & North Africa (developing only) in 2005 and the Value added (constant 2005 US$) in Tanzania in 2008?
Offer a terse response. 2.88e+11. What is the difference between the Value added (constant 2005 US$) in Antigua and Barbuda in 2005 and the Value added (constant 2005 US$) in Nigeria in 2008?
Offer a very short reply. -3.76e+1. What is the difference between the Value added (constant 2005 US$) of Antigua and Barbuda in 2005 and the Value added (constant 2005 US$) of Tanzania in 2008?
Ensure brevity in your answer.  -8.50e+09. What is the difference between the Value added (constant 2005 US$) of Nigeria in 2005 and the Value added (constant 2005 US$) of Tanzania in 2008?
Your answer should be very brief. 1.72e+1. What is the difference between the Value added (constant 2005 US$) of Middle East & North Africa (developing only) in 2005 and the Value added (constant 2005 US$) of Antigua and Barbuda in 2009?
Ensure brevity in your answer.  2.97e+11. What is the difference between the Value added (constant 2005 US$) in Middle East & North Africa (developing only) in 2005 and the Value added (constant 2005 US$) in Nigeria in 2009?
Give a very brief answer. 2.54e+11. What is the difference between the Value added (constant 2005 US$) of Middle East & North Africa (developing only) in 2005 and the Value added (constant 2005 US$) of Tanzania in 2009?
Your answer should be compact. 2.88e+11. What is the difference between the Value added (constant 2005 US$) of Antigua and Barbuda in 2005 and the Value added (constant 2005 US$) of Nigeria in 2009?
Your answer should be compact. -4.22e+1. What is the difference between the Value added (constant 2005 US$) of Antigua and Barbuda in 2005 and the Value added (constant 2005 US$) of Tanzania in 2009?
Keep it short and to the point. -8.99e+09. What is the difference between the Value added (constant 2005 US$) of Nigeria in 2005 and the Value added (constant 2005 US$) of Tanzania in 2009?
Offer a terse response. 1.67e+1. What is the difference between the Value added (constant 2005 US$) in Middle East & North Africa (developing only) in 2005 and the Value added (constant 2005 US$) in Antigua and Barbuda in 2010?
Keep it short and to the point. 2.97e+11. What is the difference between the Value added (constant 2005 US$) of Middle East & North Africa (developing only) in 2005 and the Value added (constant 2005 US$) of Nigeria in 2010?
Your answer should be very brief. 2.49e+11. What is the difference between the Value added (constant 2005 US$) in Middle East & North Africa (developing only) in 2005 and the Value added (constant 2005 US$) in Tanzania in 2010?
Ensure brevity in your answer.  2.87e+11. What is the difference between the Value added (constant 2005 US$) in Antigua and Barbuda in 2005 and the Value added (constant 2005 US$) in Nigeria in 2010?
Offer a very short reply. -4.79e+1. What is the difference between the Value added (constant 2005 US$) of Antigua and Barbuda in 2005 and the Value added (constant 2005 US$) of Tanzania in 2010?
Your response must be concise. -9.74e+09. What is the difference between the Value added (constant 2005 US$) in Nigeria in 2005 and the Value added (constant 2005 US$) in Tanzania in 2010?
Ensure brevity in your answer.  1.59e+1. What is the difference between the Value added (constant 2005 US$) of Middle East & North Africa (developing only) in 2006 and the Value added (constant 2005 US$) of Antigua and Barbuda in 2007?
Your response must be concise. 3.15e+11. What is the difference between the Value added (constant 2005 US$) of Middle East & North Africa (developing only) in 2006 and the Value added (constant 2005 US$) of Nigeria in 2007?
Ensure brevity in your answer.  2.82e+11. What is the difference between the Value added (constant 2005 US$) in Middle East & North Africa (developing only) in 2006 and the Value added (constant 2005 US$) in Tanzania in 2007?
Offer a very short reply. 3.07e+11. What is the difference between the Value added (constant 2005 US$) in Antigua and Barbuda in 2006 and the Value added (constant 2005 US$) in Nigeria in 2007?
Provide a short and direct response. -3.31e+1. What is the difference between the Value added (constant 2005 US$) in Antigua and Barbuda in 2006 and the Value added (constant 2005 US$) in Tanzania in 2007?
Make the answer very short. -8.08e+09. What is the difference between the Value added (constant 2005 US$) in Nigeria in 2006 and the Value added (constant 2005 US$) in Tanzania in 2007?
Your answer should be very brief. 2.10e+1. What is the difference between the Value added (constant 2005 US$) in Middle East & North Africa (developing only) in 2006 and the Value added (constant 2005 US$) in Antigua and Barbuda in 2008?
Offer a terse response. 3.15e+11. What is the difference between the Value added (constant 2005 US$) in Middle East & North Africa (developing only) in 2006 and the Value added (constant 2005 US$) in Nigeria in 2008?
Provide a short and direct response. 2.77e+11. What is the difference between the Value added (constant 2005 US$) in Middle East & North Africa (developing only) in 2006 and the Value added (constant 2005 US$) in Tanzania in 2008?
Keep it short and to the point. 3.06e+11. What is the difference between the Value added (constant 2005 US$) in Antigua and Barbuda in 2006 and the Value added (constant 2005 US$) in Nigeria in 2008?
Provide a short and direct response. -3.75e+1. What is the difference between the Value added (constant 2005 US$) in Antigua and Barbuda in 2006 and the Value added (constant 2005 US$) in Tanzania in 2008?
Make the answer very short. -8.44e+09. What is the difference between the Value added (constant 2005 US$) of Nigeria in 2006 and the Value added (constant 2005 US$) of Tanzania in 2008?
Provide a succinct answer. 2.06e+1. What is the difference between the Value added (constant 2005 US$) in Middle East & North Africa (developing only) in 2006 and the Value added (constant 2005 US$) in Antigua and Barbuda in 2009?
Offer a terse response. 3.15e+11. What is the difference between the Value added (constant 2005 US$) of Middle East & North Africa (developing only) in 2006 and the Value added (constant 2005 US$) of Nigeria in 2009?
Your answer should be compact. 2.72e+11. What is the difference between the Value added (constant 2005 US$) in Middle East & North Africa (developing only) in 2006 and the Value added (constant 2005 US$) in Tanzania in 2009?
Your answer should be very brief. 3.06e+11. What is the difference between the Value added (constant 2005 US$) of Antigua and Barbuda in 2006 and the Value added (constant 2005 US$) of Nigeria in 2009?
Ensure brevity in your answer.  -4.21e+1. What is the difference between the Value added (constant 2005 US$) in Antigua and Barbuda in 2006 and the Value added (constant 2005 US$) in Tanzania in 2009?
Your answer should be very brief. -8.94e+09. What is the difference between the Value added (constant 2005 US$) in Nigeria in 2006 and the Value added (constant 2005 US$) in Tanzania in 2009?
Give a very brief answer. 2.01e+1. What is the difference between the Value added (constant 2005 US$) in Middle East & North Africa (developing only) in 2006 and the Value added (constant 2005 US$) in Antigua and Barbuda in 2010?
Provide a succinct answer. 3.15e+11. What is the difference between the Value added (constant 2005 US$) of Middle East & North Africa (developing only) in 2006 and the Value added (constant 2005 US$) of Nigeria in 2010?
Provide a short and direct response. 2.67e+11. What is the difference between the Value added (constant 2005 US$) of Middle East & North Africa (developing only) in 2006 and the Value added (constant 2005 US$) of Tanzania in 2010?
Keep it short and to the point. 3.05e+11. What is the difference between the Value added (constant 2005 US$) of Antigua and Barbuda in 2006 and the Value added (constant 2005 US$) of Nigeria in 2010?
Provide a short and direct response. -4.78e+1. What is the difference between the Value added (constant 2005 US$) of Antigua and Barbuda in 2006 and the Value added (constant 2005 US$) of Tanzania in 2010?
Your answer should be very brief. -9.69e+09. What is the difference between the Value added (constant 2005 US$) in Nigeria in 2006 and the Value added (constant 2005 US$) in Tanzania in 2010?
Give a very brief answer. 1.94e+1. What is the difference between the Value added (constant 2005 US$) of Middle East & North Africa (developing only) in 2007 and the Value added (constant 2005 US$) of Antigua and Barbuda in 2008?
Keep it short and to the point. 3.41e+11. What is the difference between the Value added (constant 2005 US$) of Middle East & North Africa (developing only) in 2007 and the Value added (constant 2005 US$) of Nigeria in 2008?
Your response must be concise. 3.03e+11. What is the difference between the Value added (constant 2005 US$) in Middle East & North Africa (developing only) in 2007 and the Value added (constant 2005 US$) in Tanzania in 2008?
Ensure brevity in your answer.  3.32e+11. What is the difference between the Value added (constant 2005 US$) in Antigua and Barbuda in 2007 and the Value added (constant 2005 US$) in Nigeria in 2008?
Your answer should be compact. -3.75e+1. What is the difference between the Value added (constant 2005 US$) of Antigua and Barbuda in 2007 and the Value added (constant 2005 US$) of Tanzania in 2008?
Offer a terse response. -8.39e+09. What is the difference between the Value added (constant 2005 US$) in Nigeria in 2007 and the Value added (constant 2005 US$) in Tanzania in 2008?
Your answer should be compact. 2.46e+1. What is the difference between the Value added (constant 2005 US$) of Middle East & North Africa (developing only) in 2007 and the Value added (constant 2005 US$) of Antigua and Barbuda in 2009?
Provide a succinct answer. 3.41e+11. What is the difference between the Value added (constant 2005 US$) in Middle East & North Africa (developing only) in 2007 and the Value added (constant 2005 US$) in Nigeria in 2009?
Offer a terse response. 2.99e+11. What is the difference between the Value added (constant 2005 US$) in Middle East & North Africa (developing only) in 2007 and the Value added (constant 2005 US$) in Tanzania in 2009?
Give a very brief answer. 3.32e+11. What is the difference between the Value added (constant 2005 US$) in Antigua and Barbuda in 2007 and the Value added (constant 2005 US$) in Nigeria in 2009?
Your response must be concise. -4.21e+1. What is the difference between the Value added (constant 2005 US$) in Antigua and Barbuda in 2007 and the Value added (constant 2005 US$) in Tanzania in 2009?
Make the answer very short. -8.88e+09. What is the difference between the Value added (constant 2005 US$) in Nigeria in 2007 and the Value added (constant 2005 US$) in Tanzania in 2009?
Your answer should be compact. 2.41e+1. What is the difference between the Value added (constant 2005 US$) in Middle East & North Africa (developing only) in 2007 and the Value added (constant 2005 US$) in Antigua and Barbuda in 2010?
Ensure brevity in your answer.  3.41e+11. What is the difference between the Value added (constant 2005 US$) in Middle East & North Africa (developing only) in 2007 and the Value added (constant 2005 US$) in Nigeria in 2010?
Keep it short and to the point. 2.93e+11. What is the difference between the Value added (constant 2005 US$) of Middle East & North Africa (developing only) in 2007 and the Value added (constant 2005 US$) of Tanzania in 2010?
Give a very brief answer. 3.31e+11. What is the difference between the Value added (constant 2005 US$) of Antigua and Barbuda in 2007 and the Value added (constant 2005 US$) of Nigeria in 2010?
Give a very brief answer. -4.78e+1. What is the difference between the Value added (constant 2005 US$) in Antigua and Barbuda in 2007 and the Value added (constant 2005 US$) in Tanzania in 2010?
Your answer should be very brief. -9.64e+09. What is the difference between the Value added (constant 2005 US$) of Nigeria in 2007 and the Value added (constant 2005 US$) of Tanzania in 2010?
Give a very brief answer. 2.34e+1. What is the difference between the Value added (constant 2005 US$) in Middle East & North Africa (developing only) in 2008 and the Value added (constant 2005 US$) in Antigua and Barbuda in 2009?
Your response must be concise. 3.57e+11. What is the difference between the Value added (constant 2005 US$) of Middle East & North Africa (developing only) in 2008 and the Value added (constant 2005 US$) of Nigeria in 2009?
Provide a succinct answer. 3.15e+11. What is the difference between the Value added (constant 2005 US$) in Middle East & North Africa (developing only) in 2008 and the Value added (constant 2005 US$) in Tanzania in 2009?
Keep it short and to the point. 3.49e+11. What is the difference between the Value added (constant 2005 US$) in Antigua and Barbuda in 2008 and the Value added (constant 2005 US$) in Nigeria in 2009?
Your answer should be very brief. -4.21e+1. What is the difference between the Value added (constant 2005 US$) of Antigua and Barbuda in 2008 and the Value added (constant 2005 US$) of Tanzania in 2009?
Ensure brevity in your answer.  -8.87e+09. What is the difference between the Value added (constant 2005 US$) in Nigeria in 2008 and the Value added (constant 2005 US$) in Tanzania in 2009?
Keep it short and to the point. 2.86e+1. What is the difference between the Value added (constant 2005 US$) in Middle East & North Africa (developing only) in 2008 and the Value added (constant 2005 US$) in Antigua and Barbuda in 2010?
Your answer should be very brief. 3.58e+11. What is the difference between the Value added (constant 2005 US$) in Middle East & North Africa (developing only) in 2008 and the Value added (constant 2005 US$) in Nigeria in 2010?
Your response must be concise. 3.10e+11. What is the difference between the Value added (constant 2005 US$) in Middle East & North Africa (developing only) in 2008 and the Value added (constant 2005 US$) in Tanzania in 2010?
Your response must be concise. 3.48e+11. What is the difference between the Value added (constant 2005 US$) in Antigua and Barbuda in 2008 and the Value added (constant 2005 US$) in Nigeria in 2010?
Your answer should be very brief. -4.78e+1. What is the difference between the Value added (constant 2005 US$) in Antigua and Barbuda in 2008 and the Value added (constant 2005 US$) in Tanzania in 2010?
Offer a very short reply. -9.62e+09. What is the difference between the Value added (constant 2005 US$) in Nigeria in 2008 and the Value added (constant 2005 US$) in Tanzania in 2010?
Your response must be concise. 2.78e+1. What is the difference between the Value added (constant 2005 US$) in Middle East & North Africa (developing only) in 2009 and the Value added (constant 2005 US$) in Antigua and Barbuda in 2010?
Provide a short and direct response. 3.66e+11. What is the difference between the Value added (constant 2005 US$) in Middle East & North Africa (developing only) in 2009 and the Value added (constant 2005 US$) in Nigeria in 2010?
Ensure brevity in your answer.  3.18e+11. What is the difference between the Value added (constant 2005 US$) of Middle East & North Africa (developing only) in 2009 and the Value added (constant 2005 US$) of Tanzania in 2010?
Your response must be concise. 3.56e+11. What is the difference between the Value added (constant 2005 US$) in Antigua and Barbuda in 2009 and the Value added (constant 2005 US$) in Nigeria in 2010?
Make the answer very short. -4.79e+1. What is the difference between the Value added (constant 2005 US$) of Antigua and Barbuda in 2009 and the Value added (constant 2005 US$) of Tanzania in 2010?
Ensure brevity in your answer.  -9.72e+09. What is the difference between the Value added (constant 2005 US$) in Nigeria in 2009 and the Value added (constant 2005 US$) in Tanzania in 2010?
Ensure brevity in your answer.  3.24e+1. What is the average Value added (constant 2005 US$) of Middle East & North Africa (developing only) per year?
Offer a terse response. 3.25e+11. What is the average Value added (constant 2005 US$) of Antigua and Barbuda per year?
Your answer should be very brief. 7.28e+08. What is the average Value added (constant 2005 US$) in Nigeria per year?
Keep it short and to the point. 3.27e+1. What is the average Value added (constant 2005 US$) in Tanzania per year?
Give a very brief answer. 8.45e+09. In the year 2003, what is the difference between the Value added (constant 2005 US$) of Middle East & North Africa (developing only) and Value added (constant 2005 US$) of Antigua and Barbuda?
Make the answer very short. 2.54e+11. In the year 2003, what is the difference between the Value added (constant 2005 US$) of Middle East & North Africa (developing only) and Value added (constant 2005 US$) of Nigeria?
Keep it short and to the point. 2.36e+11. In the year 2003, what is the difference between the Value added (constant 2005 US$) of Middle East & North Africa (developing only) and Value added (constant 2005 US$) of Tanzania?
Make the answer very short. 2.48e+11. In the year 2003, what is the difference between the Value added (constant 2005 US$) in Antigua and Barbuda and Value added (constant 2005 US$) in Nigeria?
Your answer should be very brief. -1.78e+1. In the year 2003, what is the difference between the Value added (constant 2005 US$) in Antigua and Barbuda and Value added (constant 2005 US$) in Tanzania?
Your response must be concise. -5.88e+09. In the year 2003, what is the difference between the Value added (constant 2005 US$) of Nigeria and Value added (constant 2005 US$) of Tanzania?
Your answer should be very brief. 1.19e+1. In the year 2004, what is the difference between the Value added (constant 2005 US$) in Middle East & North Africa (developing only) and Value added (constant 2005 US$) in Antigua and Barbuda?
Offer a very short reply. 2.78e+11. In the year 2004, what is the difference between the Value added (constant 2005 US$) of Middle East & North Africa (developing only) and Value added (constant 2005 US$) of Nigeria?
Offer a very short reply. 2.55e+11. In the year 2004, what is the difference between the Value added (constant 2005 US$) of Middle East & North Africa (developing only) and Value added (constant 2005 US$) of Tanzania?
Offer a very short reply. 2.71e+11. In the year 2004, what is the difference between the Value added (constant 2005 US$) in Antigua and Barbuda and Value added (constant 2005 US$) in Nigeria?
Ensure brevity in your answer.  -2.30e+1. In the year 2004, what is the difference between the Value added (constant 2005 US$) in Antigua and Barbuda and Value added (constant 2005 US$) in Tanzania?
Your response must be concise. -6.37e+09. In the year 2004, what is the difference between the Value added (constant 2005 US$) of Nigeria and Value added (constant 2005 US$) of Tanzania?
Your response must be concise. 1.67e+1. In the year 2005, what is the difference between the Value added (constant 2005 US$) of Middle East & North Africa (developing only) and Value added (constant 2005 US$) of Antigua and Barbuda?
Your answer should be very brief. 2.97e+11. In the year 2005, what is the difference between the Value added (constant 2005 US$) in Middle East & North Africa (developing only) and Value added (constant 2005 US$) in Nigeria?
Offer a terse response. 2.71e+11. In the year 2005, what is the difference between the Value added (constant 2005 US$) of Middle East & North Africa (developing only) and Value added (constant 2005 US$) of Tanzania?
Offer a terse response. 2.90e+11. In the year 2005, what is the difference between the Value added (constant 2005 US$) of Antigua and Barbuda and Value added (constant 2005 US$) of Nigeria?
Your answer should be very brief. -2.56e+1. In the year 2005, what is the difference between the Value added (constant 2005 US$) of Antigua and Barbuda and Value added (constant 2005 US$) of Tanzania?
Provide a short and direct response. -7.01e+09. In the year 2005, what is the difference between the Value added (constant 2005 US$) of Nigeria and Value added (constant 2005 US$) of Tanzania?
Your answer should be compact. 1.86e+1. In the year 2006, what is the difference between the Value added (constant 2005 US$) of Middle East & North Africa (developing only) and Value added (constant 2005 US$) of Antigua and Barbuda?
Make the answer very short. 3.15e+11. In the year 2006, what is the difference between the Value added (constant 2005 US$) of Middle East & North Africa (developing only) and Value added (constant 2005 US$) of Nigeria?
Keep it short and to the point. 2.86e+11. In the year 2006, what is the difference between the Value added (constant 2005 US$) in Middle East & North Africa (developing only) and Value added (constant 2005 US$) in Tanzania?
Keep it short and to the point. 3.07e+11. In the year 2006, what is the difference between the Value added (constant 2005 US$) in Antigua and Barbuda and Value added (constant 2005 US$) in Nigeria?
Give a very brief answer. -2.90e+1. In the year 2006, what is the difference between the Value added (constant 2005 US$) of Antigua and Barbuda and Value added (constant 2005 US$) of Tanzania?
Provide a short and direct response. -7.39e+09. In the year 2006, what is the difference between the Value added (constant 2005 US$) in Nigeria and Value added (constant 2005 US$) in Tanzania?
Ensure brevity in your answer.  2.16e+1. In the year 2007, what is the difference between the Value added (constant 2005 US$) in Middle East & North Africa (developing only) and Value added (constant 2005 US$) in Antigua and Barbuda?
Offer a very short reply. 3.41e+11. In the year 2007, what is the difference between the Value added (constant 2005 US$) in Middle East & North Africa (developing only) and Value added (constant 2005 US$) in Nigeria?
Keep it short and to the point. 3.08e+11. In the year 2007, what is the difference between the Value added (constant 2005 US$) of Middle East & North Africa (developing only) and Value added (constant 2005 US$) of Tanzania?
Offer a terse response. 3.33e+11. In the year 2007, what is the difference between the Value added (constant 2005 US$) of Antigua and Barbuda and Value added (constant 2005 US$) of Nigeria?
Keep it short and to the point. -3.30e+1. In the year 2007, what is the difference between the Value added (constant 2005 US$) in Antigua and Barbuda and Value added (constant 2005 US$) in Tanzania?
Ensure brevity in your answer.  -8.02e+09. In the year 2007, what is the difference between the Value added (constant 2005 US$) of Nigeria and Value added (constant 2005 US$) of Tanzania?
Your answer should be compact. 2.50e+1. In the year 2008, what is the difference between the Value added (constant 2005 US$) in Middle East & North Africa (developing only) and Value added (constant 2005 US$) in Antigua and Barbuda?
Keep it short and to the point. 3.57e+11. In the year 2008, what is the difference between the Value added (constant 2005 US$) in Middle East & North Africa (developing only) and Value added (constant 2005 US$) in Nigeria?
Your answer should be very brief. 3.20e+11. In the year 2008, what is the difference between the Value added (constant 2005 US$) in Middle East & North Africa (developing only) and Value added (constant 2005 US$) in Tanzania?
Offer a terse response. 3.49e+11. In the year 2008, what is the difference between the Value added (constant 2005 US$) in Antigua and Barbuda and Value added (constant 2005 US$) in Nigeria?
Provide a succinct answer. -3.75e+1. In the year 2008, what is the difference between the Value added (constant 2005 US$) of Antigua and Barbuda and Value added (constant 2005 US$) of Tanzania?
Your answer should be very brief. -8.37e+09. In the year 2008, what is the difference between the Value added (constant 2005 US$) of Nigeria and Value added (constant 2005 US$) of Tanzania?
Keep it short and to the point. 2.91e+1. In the year 2009, what is the difference between the Value added (constant 2005 US$) of Middle East & North Africa (developing only) and Value added (constant 2005 US$) of Antigua and Barbuda?
Provide a succinct answer. 3.66e+11. In the year 2009, what is the difference between the Value added (constant 2005 US$) in Middle East & North Africa (developing only) and Value added (constant 2005 US$) in Nigeria?
Make the answer very short. 3.24e+11. In the year 2009, what is the difference between the Value added (constant 2005 US$) in Middle East & North Africa (developing only) and Value added (constant 2005 US$) in Tanzania?
Offer a very short reply. 3.57e+11. In the year 2009, what is the difference between the Value added (constant 2005 US$) in Antigua and Barbuda and Value added (constant 2005 US$) in Nigeria?
Keep it short and to the point. -4.22e+1. In the year 2009, what is the difference between the Value added (constant 2005 US$) of Antigua and Barbuda and Value added (constant 2005 US$) of Tanzania?
Ensure brevity in your answer.  -8.96e+09. In the year 2009, what is the difference between the Value added (constant 2005 US$) in Nigeria and Value added (constant 2005 US$) in Tanzania?
Keep it short and to the point. 3.32e+1. In the year 2010, what is the difference between the Value added (constant 2005 US$) in Middle East & North Africa (developing only) and Value added (constant 2005 US$) in Antigua and Barbuda?
Your response must be concise. 3.87e+11. In the year 2010, what is the difference between the Value added (constant 2005 US$) in Middle East & North Africa (developing only) and Value added (constant 2005 US$) in Nigeria?
Offer a terse response. 3.39e+11. In the year 2010, what is the difference between the Value added (constant 2005 US$) of Middle East & North Africa (developing only) and Value added (constant 2005 US$) of Tanzania?
Provide a succinct answer. 3.78e+11. In the year 2010, what is the difference between the Value added (constant 2005 US$) of Antigua and Barbuda and Value added (constant 2005 US$) of Nigeria?
Ensure brevity in your answer.  -4.79e+1. In the year 2010, what is the difference between the Value added (constant 2005 US$) in Antigua and Barbuda and Value added (constant 2005 US$) in Tanzania?
Provide a short and direct response. -9.74e+09. In the year 2010, what is the difference between the Value added (constant 2005 US$) in Nigeria and Value added (constant 2005 US$) in Tanzania?
Keep it short and to the point. 3.81e+1. What is the ratio of the Value added (constant 2005 US$) of Middle East & North Africa (developing only) in 2003 to that in 2004?
Give a very brief answer. 0.91. What is the ratio of the Value added (constant 2005 US$) in Antigua and Barbuda in 2003 to that in 2004?
Keep it short and to the point. 0.96. What is the ratio of the Value added (constant 2005 US$) in Nigeria in 2003 to that in 2004?
Keep it short and to the point. 0.78. What is the ratio of the Value added (constant 2005 US$) in Tanzania in 2003 to that in 2004?
Offer a very short reply. 0.93. What is the ratio of the Value added (constant 2005 US$) of Middle East & North Africa (developing only) in 2003 to that in 2005?
Keep it short and to the point. 0.86. What is the ratio of the Value added (constant 2005 US$) in Antigua and Barbuda in 2003 to that in 2005?
Provide a succinct answer. 0.92. What is the ratio of the Value added (constant 2005 US$) of Nigeria in 2003 to that in 2005?
Make the answer very short. 0.7. What is the ratio of the Value added (constant 2005 US$) in Tanzania in 2003 to that in 2005?
Your answer should be compact. 0.85. What is the ratio of the Value added (constant 2005 US$) of Middle East & North Africa (developing only) in 2003 to that in 2006?
Make the answer very short. 0.81. What is the ratio of the Value added (constant 2005 US$) in Antigua and Barbuda in 2003 to that in 2006?
Ensure brevity in your answer.  0.86. What is the ratio of the Value added (constant 2005 US$) of Nigeria in 2003 to that in 2006?
Offer a very short reply. 0.62. What is the ratio of the Value added (constant 2005 US$) of Tanzania in 2003 to that in 2006?
Offer a terse response. 0.8. What is the ratio of the Value added (constant 2005 US$) in Middle East & North Africa (developing only) in 2003 to that in 2007?
Give a very brief answer. 0.74. What is the ratio of the Value added (constant 2005 US$) of Antigua and Barbuda in 2003 to that in 2007?
Make the answer very short. 0.8. What is the ratio of the Value added (constant 2005 US$) in Nigeria in 2003 to that in 2007?
Keep it short and to the point. 0.55. What is the ratio of the Value added (constant 2005 US$) in Tanzania in 2003 to that in 2007?
Make the answer very short. 0.74. What is the ratio of the Value added (constant 2005 US$) of Middle East & North Africa (developing only) in 2003 to that in 2008?
Make the answer very short. 0.71. What is the ratio of the Value added (constant 2005 US$) of Antigua and Barbuda in 2003 to that in 2008?
Offer a very short reply. 0.78. What is the ratio of the Value added (constant 2005 US$) of Nigeria in 2003 to that in 2008?
Provide a short and direct response. 0.48. What is the ratio of the Value added (constant 2005 US$) in Tanzania in 2003 to that in 2008?
Give a very brief answer. 0.71. What is the ratio of the Value added (constant 2005 US$) of Middle East & North Africa (developing only) in 2003 to that in 2009?
Make the answer very short. 0.69. What is the ratio of the Value added (constant 2005 US$) of Antigua and Barbuda in 2003 to that in 2009?
Offer a terse response. 0.89. What is the ratio of the Value added (constant 2005 US$) in Nigeria in 2003 to that in 2009?
Ensure brevity in your answer.  0.43. What is the ratio of the Value added (constant 2005 US$) in Tanzania in 2003 to that in 2009?
Your response must be concise. 0.67. What is the ratio of the Value added (constant 2005 US$) in Middle East & North Africa (developing only) in 2003 to that in 2010?
Your answer should be very brief. 0.66. What is the ratio of the Value added (constant 2005 US$) in Antigua and Barbuda in 2003 to that in 2010?
Offer a very short reply. 0.92. What is the ratio of the Value added (constant 2005 US$) in Nigeria in 2003 to that in 2010?
Provide a short and direct response. 0.38. What is the ratio of the Value added (constant 2005 US$) in Tanzania in 2003 to that in 2010?
Offer a terse response. 0.63. What is the ratio of the Value added (constant 2005 US$) of Middle East & North Africa (developing only) in 2004 to that in 2005?
Your response must be concise. 0.94. What is the ratio of the Value added (constant 2005 US$) of Antigua and Barbuda in 2004 to that in 2005?
Give a very brief answer. 0.96. What is the ratio of the Value added (constant 2005 US$) of Nigeria in 2004 to that in 2005?
Keep it short and to the point. 0.9. What is the ratio of the Value added (constant 2005 US$) in Tanzania in 2004 to that in 2005?
Ensure brevity in your answer.  0.91. What is the ratio of the Value added (constant 2005 US$) of Middle East & North Africa (developing only) in 2004 to that in 2006?
Provide a short and direct response. 0.88. What is the ratio of the Value added (constant 2005 US$) in Antigua and Barbuda in 2004 to that in 2006?
Give a very brief answer. 0.89. What is the ratio of the Value added (constant 2005 US$) in Nigeria in 2004 to that in 2006?
Your answer should be compact. 0.8. What is the ratio of the Value added (constant 2005 US$) of Tanzania in 2004 to that in 2006?
Keep it short and to the point. 0.86. What is the ratio of the Value added (constant 2005 US$) in Middle East & North Africa (developing only) in 2004 to that in 2007?
Your response must be concise. 0.82. What is the ratio of the Value added (constant 2005 US$) in Antigua and Barbuda in 2004 to that in 2007?
Give a very brief answer. 0.83. What is the ratio of the Value added (constant 2005 US$) of Nigeria in 2004 to that in 2007?
Your answer should be very brief. 0.7. What is the ratio of the Value added (constant 2005 US$) of Tanzania in 2004 to that in 2007?
Give a very brief answer. 0.8. What is the ratio of the Value added (constant 2005 US$) of Middle East & North Africa (developing only) in 2004 to that in 2008?
Provide a short and direct response. 0.78. What is the ratio of the Value added (constant 2005 US$) in Antigua and Barbuda in 2004 to that in 2008?
Your answer should be very brief. 0.81. What is the ratio of the Value added (constant 2005 US$) of Nigeria in 2004 to that in 2008?
Offer a very short reply. 0.62. What is the ratio of the Value added (constant 2005 US$) in Tanzania in 2004 to that in 2008?
Keep it short and to the point. 0.77. What is the ratio of the Value added (constant 2005 US$) in Middle East & North Africa (developing only) in 2004 to that in 2009?
Offer a very short reply. 0.76. What is the ratio of the Value added (constant 2005 US$) of Antigua and Barbuda in 2004 to that in 2009?
Your response must be concise. 0.92. What is the ratio of the Value added (constant 2005 US$) in Nigeria in 2004 to that in 2009?
Offer a very short reply. 0.55. What is the ratio of the Value added (constant 2005 US$) in Tanzania in 2004 to that in 2009?
Your answer should be very brief. 0.73. What is the ratio of the Value added (constant 2005 US$) of Middle East & North Africa (developing only) in 2004 to that in 2010?
Make the answer very short. 0.72. What is the ratio of the Value added (constant 2005 US$) of Antigua and Barbuda in 2004 to that in 2010?
Make the answer very short. 0.96. What is the ratio of the Value added (constant 2005 US$) in Nigeria in 2004 to that in 2010?
Provide a succinct answer. 0.49. What is the ratio of the Value added (constant 2005 US$) of Tanzania in 2004 to that in 2010?
Offer a terse response. 0.67. What is the ratio of the Value added (constant 2005 US$) in Middle East & North Africa (developing only) in 2005 to that in 2006?
Make the answer very short. 0.94. What is the ratio of the Value added (constant 2005 US$) of Antigua and Barbuda in 2005 to that in 2006?
Provide a short and direct response. 0.93. What is the ratio of the Value added (constant 2005 US$) in Nigeria in 2005 to that in 2006?
Keep it short and to the point. 0.88. What is the ratio of the Value added (constant 2005 US$) in Tanzania in 2005 to that in 2006?
Provide a short and direct response. 0.95. What is the ratio of the Value added (constant 2005 US$) in Middle East & North Africa (developing only) in 2005 to that in 2007?
Your response must be concise. 0.87. What is the ratio of the Value added (constant 2005 US$) in Antigua and Barbuda in 2005 to that in 2007?
Your answer should be very brief. 0.87. What is the ratio of the Value added (constant 2005 US$) in Nigeria in 2005 to that in 2007?
Your answer should be very brief. 0.78. What is the ratio of the Value added (constant 2005 US$) of Tanzania in 2005 to that in 2007?
Ensure brevity in your answer.  0.87. What is the ratio of the Value added (constant 2005 US$) of Middle East & North Africa (developing only) in 2005 to that in 2008?
Offer a very short reply. 0.83. What is the ratio of the Value added (constant 2005 US$) in Antigua and Barbuda in 2005 to that in 2008?
Make the answer very short. 0.85. What is the ratio of the Value added (constant 2005 US$) of Nigeria in 2005 to that in 2008?
Give a very brief answer. 0.69. What is the ratio of the Value added (constant 2005 US$) of Tanzania in 2005 to that in 2008?
Offer a very short reply. 0.84. What is the ratio of the Value added (constant 2005 US$) in Middle East & North Africa (developing only) in 2005 to that in 2009?
Your answer should be very brief. 0.81. What is the ratio of the Value added (constant 2005 US$) in Antigua and Barbuda in 2005 to that in 2009?
Keep it short and to the point. 0.96. What is the ratio of the Value added (constant 2005 US$) in Nigeria in 2005 to that in 2009?
Provide a succinct answer. 0.61. What is the ratio of the Value added (constant 2005 US$) in Tanzania in 2005 to that in 2009?
Give a very brief answer. 0.8. What is the ratio of the Value added (constant 2005 US$) of Middle East & North Africa (developing only) in 2005 to that in 2010?
Give a very brief answer. 0.77. What is the ratio of the Value added (constant 2005 US$) of Nigeria in 2005 to that in 2010?
Ensure brevity in your answer.  0.54. What is the ratio of the Value added (constant 2005 US$) in Tanzania in 2005 to that in 2010?
Ensure brevity in your answer.  0.74. What is the ratio of the Value added (constant 2005 US$) of Middle East & North Africa (developing only) in 2006 to that in 2007?
Make the answer very short. 0.92. What is the ratio of the Value added (constant 2005 US$) of Antigua and Barbuda in 2006 to that in 2007?
Your response must be concise. 0.93. What is the ratio of the Value added (constant 2005 US$) of Nigeria in 2006 to that in 2007?
Offer a very short reply. 0.88. What is the ratio of the Value added (constant 2005 US$) of Tanzania in 2006 to that in 2007?
Provide a short and direct response. 0.92. What is the ratio of the Value added (constant 2005 US$) in Middle East & North Africa (developing only) in 2006 to that in 2008?
Offer a terse response. 0.88. What is the ratio of the Value added (constant 2005 US$) in Antigua and Barbuda in 2006 to that in 2008?
Your response must be concise. 0.92. What is the ratio of the Value added (constant 2005 US$) in Nigeria in 2006 to that in 2008?
Give a very brief answer. 0.78. What is the ratio of the Value added (constant 2005 US$) in Tanzania in 2006 to that in 2008?
Offer a terse response. 0.89. What is the ratio of the Value added (constant 2005 US$) of Middle East & North Africa (developing only) in 2006 to that in 2009?
Your answer should be compact. 0.86. What is the ratio of the Value added (constant 2005 US$) of Antigua and Barbuda in 2006 to that in 2009?
Your answer should be very brief. 1.04. What is the ratio of the Value added (constant 2005 US$) in Nigeria in 2006 to that in 2009?
Your response must be concise. 0.69. What is the ratio of the Value added (constant 2005 US$) in Tanzania in 2006 to that in 2009?
Keep it short and to the point. 0.84. What is the ratio of the Value added (constant 2005 US$) of Middle East & North Africa (developing only) in 2006 to that in 2010?
Give a very brief answer. 0.81. What is the ratio of the Value added (constant 2005 US$) in Nigeria in 2006 to that in 2010?
Offer a very short reply. 0.61. What is the ratio of the Value added (constant 2005 US$) of Tanzania in 2006 to that in 2010?
Make the answer very short. 0.78. What is the ratio of the Value added (constant 2005 US$) in Middle East & North Africa (developing only) in 2007 to that in 2008?
Make the answer very short. 0.95. What is the ratio of the Value added (constant 2005 US$) in Antigua and Barbuda in 2007 to that in 2008?
Keep it short and to the point. 0.98. What is the ratio of the Value added (constant 2005 US$) of Nigeria in 2007 to that in 2008?
Provide a short and direct response. 0.88. What is the ratio of the Value added (constant 2005 US$) in Tanzania in 2007 to that in 2008?
Make the answer very short. 0.96. What is the ratio of the Value added (constant 2005 US$) of Middle East & North Africa (developing only) in 2007 to that in 2009?
Ensure brevity in your answer.  0.93. What is the ratio of the Value added (constant 2005 US$) in Antigua and Barbuda in 2007 to that in 2009?
Ensure brevity in your answer.  1.11. What is the ratio of the Value added (constant 2005 US$) in Nigeria in 2007 to that in 2009?
Provide a succinct answer. 0.79. What is the ratio of the Value added (constant 2005 US$) of Tanzania in 2007 to that in 2009?
Give a very brief answer. 0.91. What is the ratio of the Value added (constant 2005 US$) of Middle East & North Africa (developing only) in 2007 to that in 2010?
Provide a short and direct response. 0.88. What is the ratio of the Value added (constant 2005 US$) in Antigua and Barbuda in 2007 to that in 2010?
Ensure brevity in your answer.  1.15. What is the ratio of the Value added (constant 2005 US$) in Nigeria in 2007 to that in 2010?
Your answer should be very brief. 0.7. What is the ratio of the Value added (constant 2005 US$) of Tanzania in 2007 to that in 2010?
Your answer should be compact. 0.85. What is the ratio of the Value added (constant 2005 US$) in Middle East & North Africa (developing only) in 2008 to that in 2009?
Your answer should be compact. 0.98. What is the ratio of the Value added (constant 2005 US$) of Antigua and Barbuda in 2008 to that in 2009?
Ensure brevity in your answer.  1.13. What is the ratio of the Value added (constant 2005 US$) in Nigeria in 2008 to that in 2009?
Provide a succinct answer. 0.89. What is the ratio of the Value added (constant 2005 US$) of Tanzania in 2008 to that in 2009?
Your response must be concise. 0.95. What is the ratio of the Value added (constant 2005 US$) of Middle East & North Africa (developing only) in 2008 to that in 2010?
Give a very brief answer. 0.92. What is the ratio of the Value added (constant 2005 US$) in Antigua and Barbuda in 2008 to that in 2010?
Your response must be concise. 1.18. What is the ratio of the Value added (constant 2005 US$) in Nigeria in 2008 to that in 2010?
Your answer should be compact. 0.79. What is the ratio of the Value added (constant 2005 US$) in Tanzania in 2008 to that in 2010?
Your response must be concise. 0.88. What is the ratio of the Value added (constant 2005 US$) of Middle East & North Africa (developing only) in 2009 to that in 2010?
Offer a terse response. 0.95. What is the ratio of the Value added (constant 2005 US$) of Antigua and Barbuda in 2009 to that in 2010?
Provide a succinct answer. 1.04. What is the ratio of the Value added (constant 2005 US$) in Nigeria in 2009 to that in 2010?
Offer a very short reply. 0.88. What is the ratio of the Value added (constant 2005 US$) of Tanzania in 2009 to that in 2010?
Offer a very short reply. 0.93. What is the difference between the highest and the second highest Value added (constant 2005 US$) of Middle East & North Africa (developing only)?
Provide a short and direct response. 2.12e+1. What is the difference between the highest and the second highest Value added (constant 2005 US$) of Antigua and Barbuda?
Offer a very short reply. 1.68e+07. What is the difference between the highest and the second highest Value added (constant 2005 US$) of Nigeria?
Your response must be concise. 5.70e+09. What is the difference between the highest and the second highest Value added (constant 2005 US$) of Tanzania?
Offer a very short reply. 7.53e+08. What is the difference between the highest and the lowest Value added (constant 2005 US$) of Middle East & North Africa (developing only)?
Provide a succinct answer. 1.34e+11. What is the difference between the highest and the lowest Value added (constant 2005 US$) of Antigua and Barbuda?
Make the answer very short. 1.78e+08. What is the difference between the highest and the lowest Value added (constant 2005 US$) of Nigeria?
Give a very brief answer. 3.01e+1. What is the difference between the highest and the lowest Value added (constant 2005 US$) in Tanzania?
Offer a terse response. 3.91e+09. 